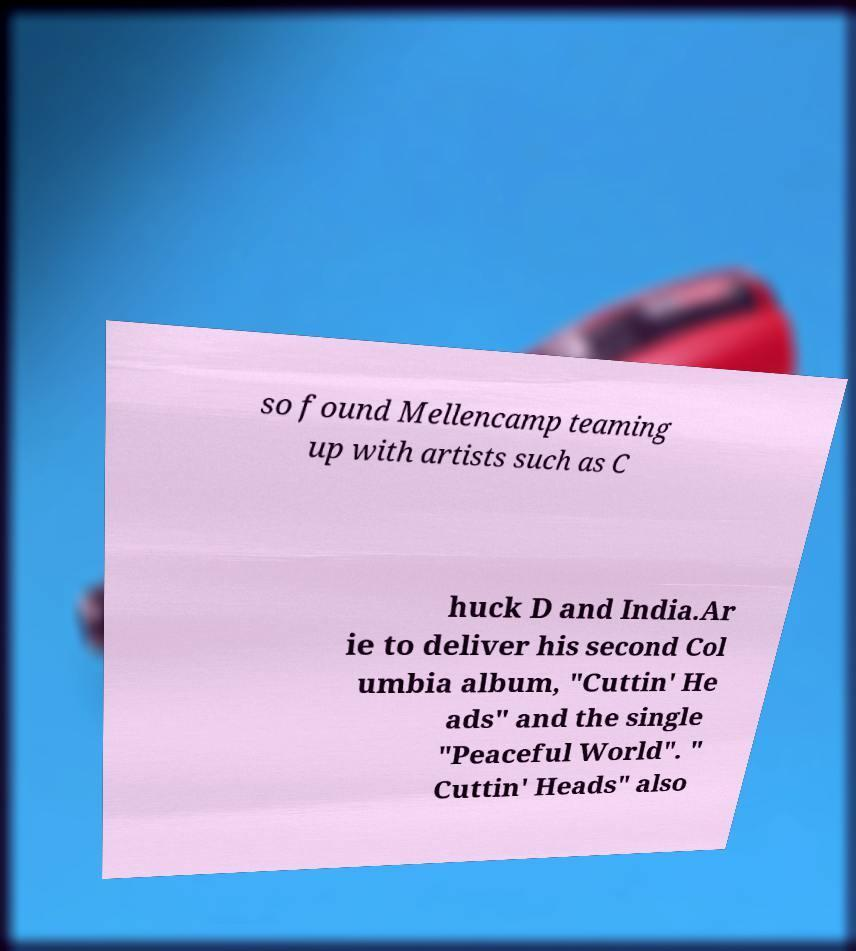Please read and relay the text visible in this image. What does it say? so found Mellencamp teaming up with artists such as C huck D and India.Ar ie to deliver his second Col umbia album, "Cuttin' He ads" and the single "Peaceful World". " Cuttin' Heads" also 